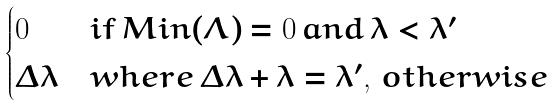Convert formula to latex. <formula><loc_0><loc_0><loc_500><loc_500>\begin{cases} 0 & i f \, M i n ( \Lambda ) = 0 \, a n d \, \lambda < \lambda ^ { \prime } \\ \Delta \lambda & w h e r e \, \Delta \lambda + \lambda = \lambda ^ { \prime } , \, o t h e r w i s e \end{cases}</formula> 